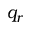Convert formula to latex. <formula><loc_0><loc_0><loc_500><loc_500>q _ { r }</formula> 